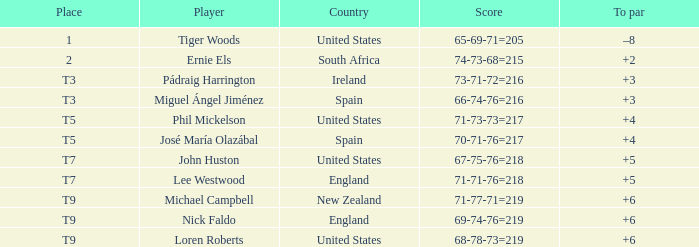What is Player, when Country is "England", and when Place is "T7"? Lee Westwood. 